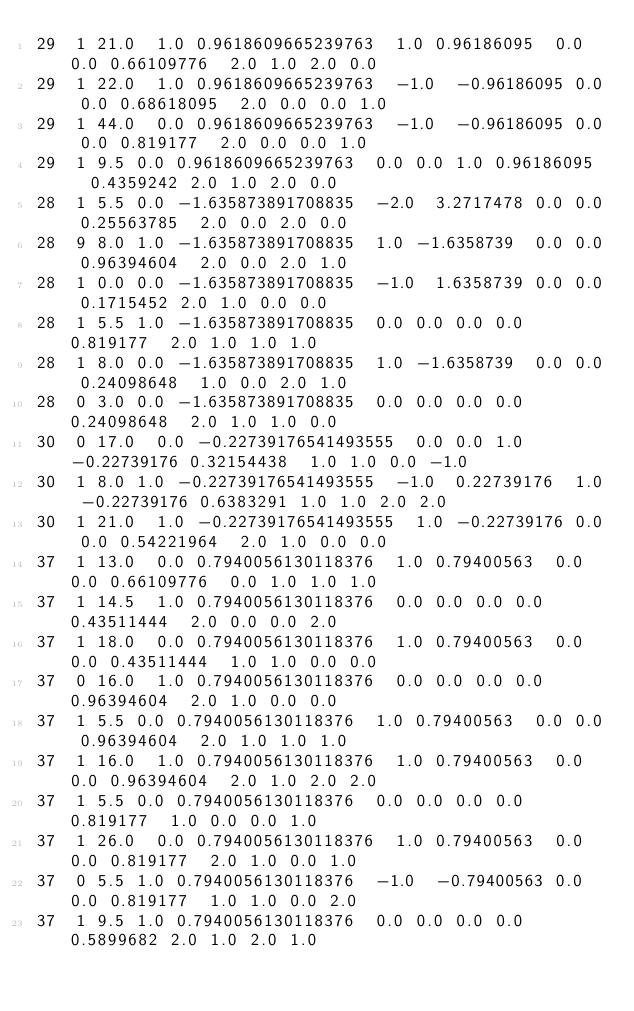<code> <loc_0><loc_0><loc_500><loc_500><_SQL_>29	1	21.0	1.0	0.9618609665239763	1.0	0.96186095	0.0	0.0	0.66109776	2.0	1.0	2.0	0.0
29	1	22.0	1.0	0.9618609665239763	-1.0	-0.96186095	0.0	0.0	0.68618095	2.0	0.0	0.0	1.0
29	1	44.0	0.0	0.9618609665239763	-1.0	-0.96186095	0.0	0.0	0.819177	2.0	0.0	0.0	1.0
29	1	9.5	0.0	0.9618609665239763	0.0	0.0	1.0	0.96186095	0.4359242	2.0	1.0	2.0	0.0
28	1	5.5	0.0	-1.635873891708835	-2.0	3.2717478	0.0	0.0	0.25563785	2.0	0.0	2.0	0.0
28	9	8.0	1.0	-1.635873891708835	1.0	-1.6358739	0.0	0.0	0.96394604	2.0	0.0	2.0	1.0
28	1	0.0	0.0	-1.635873891708835	-1.0	1.6358739	0.0	0.0	0.1715452	2.0	1.0	0.0	0.0
28	1	5.5	1.0	-1.635873891708835	0.0	0.0	0.0	0.0	0.819177	2.0	1.0	1.0	1.0
28	1	8.0	0.0	-1.635873891708835	1.0	-1.6358739	0.0	0.0	0.24098648	1.0	0.0	2.0	1.0
28	0	3.0	0.0	-1.635873891708835	0.0	0.0	0.0	0.0	0.24098648	2.0	1.0	1.0	0.0
30	0	17.0	0.0	-0.22739176541493555	0.0	0.0	1.0	-0.22739176	0.32154438	1.0	1.0	0.0	-1.0
30	1	8.0	1.0	-0.22739176541493555	-1.0	0.22739176	1.0	-0.22739176	0.6383291	1.0	1.0	2.0	2.0
30	1	21.0	1.0	-0.22739176541493555	1.0	-0.22739176	0.0	0.0	0.54221964	2.0	1.0	0.0	0.0
37	1	13.0	0.0	0.7940056130118376	1.0	0.79400563	0.0	0.0	0.66109776	0.0	1.0	1.0	1.0
37	1	14.5	1.0	0.7940056130118376	0.0	0.0	0.0	0.0	0.43511444	2.0	0.0	0.0	2.0
37	1	18.0	0.0	0.7940056130118376	1.0	0.79400563	0.0	0.0	0.43511444	1.0	1.0	0.0	0.0
37	0	16.0	1.0	0.7940056130118376	0.0	0.0	0.0	0.0	0.96394604	2.0	1.0	0.0	0.0
37	1	5.5	0.0	0.7940056130118376	1.0	0.79400563	0.0	0.0	0.96394604	2.0	1.0	1.0	1.0
37	1	16.0	1.0	0.7940056130118376	1.0	0.79400563	0.0	0.0	0.96394604	2.0	1.0	2.0	2.0
37	1	5.5	0.0	0.7940056130118376	0.0	0.0	0.0	0.0	0.819177	1.0	0.0	0.0	1.0
37	1	26.0	0.0	0.7940056130118376	1.0	0.79400563	0.0	0.0	0.819177	2.0	1.0	0.0	1.0
37	0	5.5	1.0	0.7940056130118376	-1.0	-0.79400563	0.0	0.0	0.819177	1.0	1.0	0.0	2.0
37	1	9.5	1.0	0.7940056130118376	0.0	0.0	0.0	0.0	0.5899682	2.0	1.0	2.0	1.0</code> 